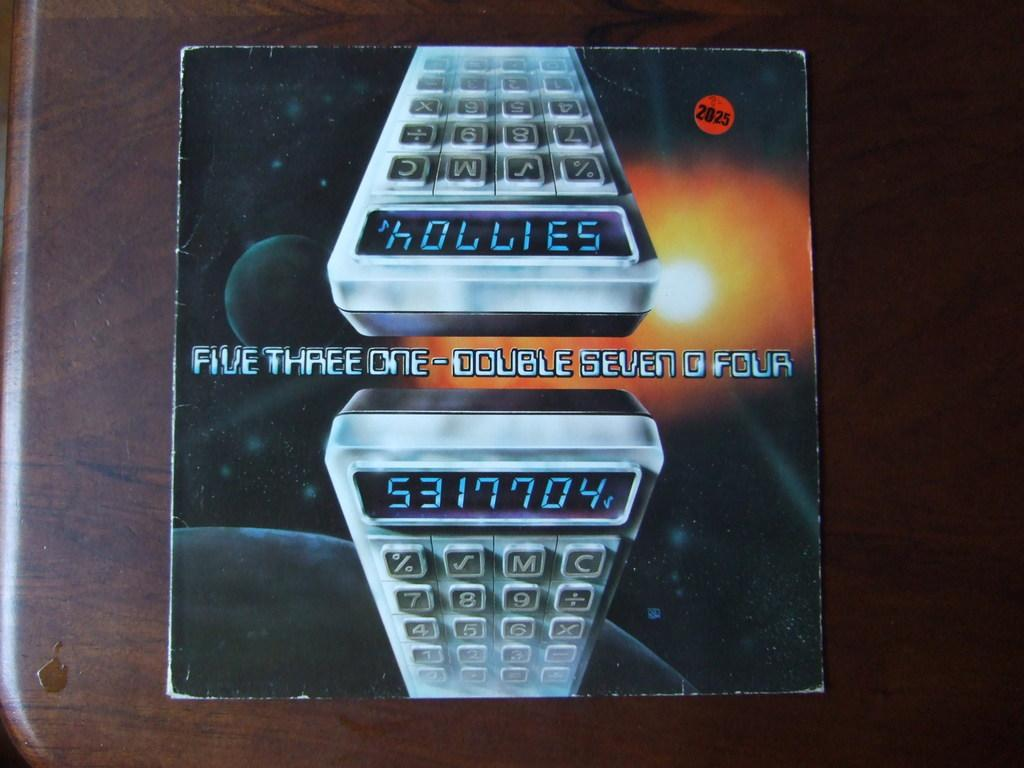Provide a one-sentence caption for the provided image. A calcular's reflection of itself on a paper with numbers 5317704 displayed on calculator. 